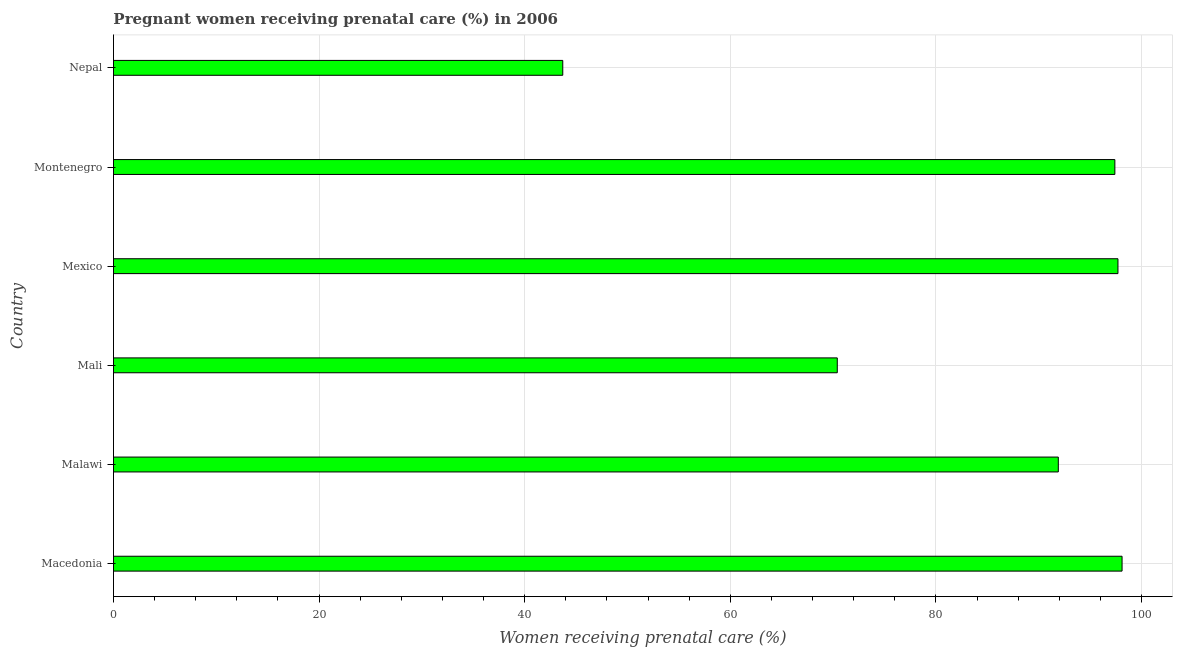Does the graph contain any zero values?
Give a very brief answer. No. Does the graph contain grids?
Keep it short and to the point. Yes. What is the title of the graph?
Offer a very short reply. Pregnant women receiving prenatal care (%) in 2006. What is the label or title of the X-axis?
Give a very brief answer. Women receiving prenatal care (%). What is the percentage of pregnant women receiving prenatal care in Nepal?
Provide a succinct answer. 43.7. Across all countries, what is the maximum percentage of pregnant women receiving prenatal care?
Your answer should be very brief. 98.1. Across all countries, what is the minimum percentage of pregnant women receiving prenatal care?
Offer a very short reply. 43.7. In which country was the percentage of pregnant women receiving prenatal care maximum?
Your response must be concise. Macedonia. In which country was the percentage of pregnant women receiving prenatal care minimum?
Your answer should be very brief. Nepal. What is the sum of the percentage of pregnant women receiving prenatal care?
Ensure brevity in your answer.  499.2. What is the difference between the percentage of pregnant women receiving prenatal care in Macedonia and Malawi?
Your answer should be very brief. 6.2. What is the average percentage of pregnant women receiving prenatal care per country?
Give a very brief answer. 83.2. What is the median percentage of pregnant women receiving prenatal care?
Your answer should be compact. 94.65. What is the ratio of the percentage of pregnant women receiving prenatal care in Mali to that in Nepal?
Provide a succinct answer. 1.61. Is the percentage of pregnant women receiving prenatal care in Malawi less than that in Mali?
Offer a terse response. No. Is the difference between the percentage of pregnant women receiving prenatal care in Macedonia and Mexico greater than the difference between any two countries?
Give a very brief answer. No. What is the difference between the highest and the lowest percentage of pregnant women receiving prenatal care?
Make the answer very short. 54.4. How many bars are there?
Keep it short and to the point. 6. Are all the bars in the graph horizontal?
Provide a short and direct response. Yes. What is the Women receiving prenatal care (%) of Macedonia?
Provide a short and direct response. 98.1. What is the Women receiving prenatal care (%) in Malawi?
Make the answer very short. 91.9. What is the Women receiving prenatal care (%) in Mali?
Offer a terse response. 70.4. What is the Women receiving prenatal care (%) in Mexico?
Ensure brevity in your answer.  97.7. What is the Women receiving prenatal care (%) of Montenegro?
Provide a short and direct response. 97.4. What is the Women receiving prenatal care (%) of Nepal?
Provide a short and direct response. 43.7. What is the difference between the Women receiving prenatal care (%) in Macedonia and Malawi?
Offer a terse response. 6.2. What is the difference between the Women receiving prenatal care (%) in Macedonia and Mali?
Keep it short and to the point. 27.7. What is the difference between the Women receiving prenatal care (%) in Macedonia and Nepal?
Provide a succinct answer. 54.4. What is the difference between the Women receiving prenatal care (%) in Malawi and Mali?
Keep it short and to the point. 21.5. What is the difference between the Women receiving prenatal care (%) in Malawi and Montenegro?
Ensure brevity in your answer.  -5.5. What is the difference between the Women receiving prenatal care (%) in Malawi and Nepal?
Provide a short and direct response. 48.2. What is the difference between the Women receiving prenatal care (%) in Mali and Mexico?
Make the answer very short. -27.3. What is the difference between the Women receiving prenatal care (%) in Mali and Montenegro?
Offer a very short reply. -27. What is the difference between the Women receiving prenatal care (%) in Mali and Nepal?
Offer a terse response. 26.7. What is the difference between the Women receiving prenatal care (%) in Mexico and Montenegro?
Your response must be concise. 0.3. What is the difference between the Women receiving prenatal care (%) in Mexico and Nepal?
Provide a short and direct response. 54. What is the difference between the Women receiving prenatal care (%) in Montenegro and Nepal?
Give a very brief answer. 53.7. What is the ratio of the Women receiving prenatal care (%) in Macedonia to that in Malawi?
Provide a succinct answer. 1.07. What is the ratio of the Women receiving prenatal care (%) in Macedonia to that in Mali?
Ensure brevity in your answer.  1.39. What is the ratio of the Women receiving prenatal care (%) in Macedonia to that in Montenegro?
Your response must be concise. 1.01. What is the ratio of the Women receiving prenatal care (%) in Macedonia to that in Nepal?
Ensure brevity in your answer.  2.25. What is the ratio of the Women receiving prenatal care (%) in Malawi to that in Mali?
Your answer should be very brief. 1.3. What is the ratio of the Women receiving prenatal care (%) in Malawi to that in Mexico?
Make the answer very short. 0.94. What is the ratio of the Women receiving prenatal care (%) in Malawi to that in Montenegro?
Offer a terse response. 0.94. What is the ratio of the Women receiving prenatal care (%) in Malawi to that in Nepal?
Provide a short and direct response. 2.1. What is the ratio of the Women receiving prenatal care (%) in Mali to that in Mexico?
Your answer should be compact. 0.72. What is the ratio of the Women receiving prenatal care (%) in Mali to that in Montenegro?
Ensure brevity in your answer.  0.72. What is the ratio of the Women receiving prenatal care (%) in Mali to that in Nepal?
Keep it short and to the point. 1.61. What is the ratio of the Women receiving prenatal care (%) in Mexico to that in Nepal?
Make the answer very short. 2.24. What is the ratio of the Women receiving prenatal care (%) in Montenegro to that in Nepal?
Offer a terse response. 2.23. 